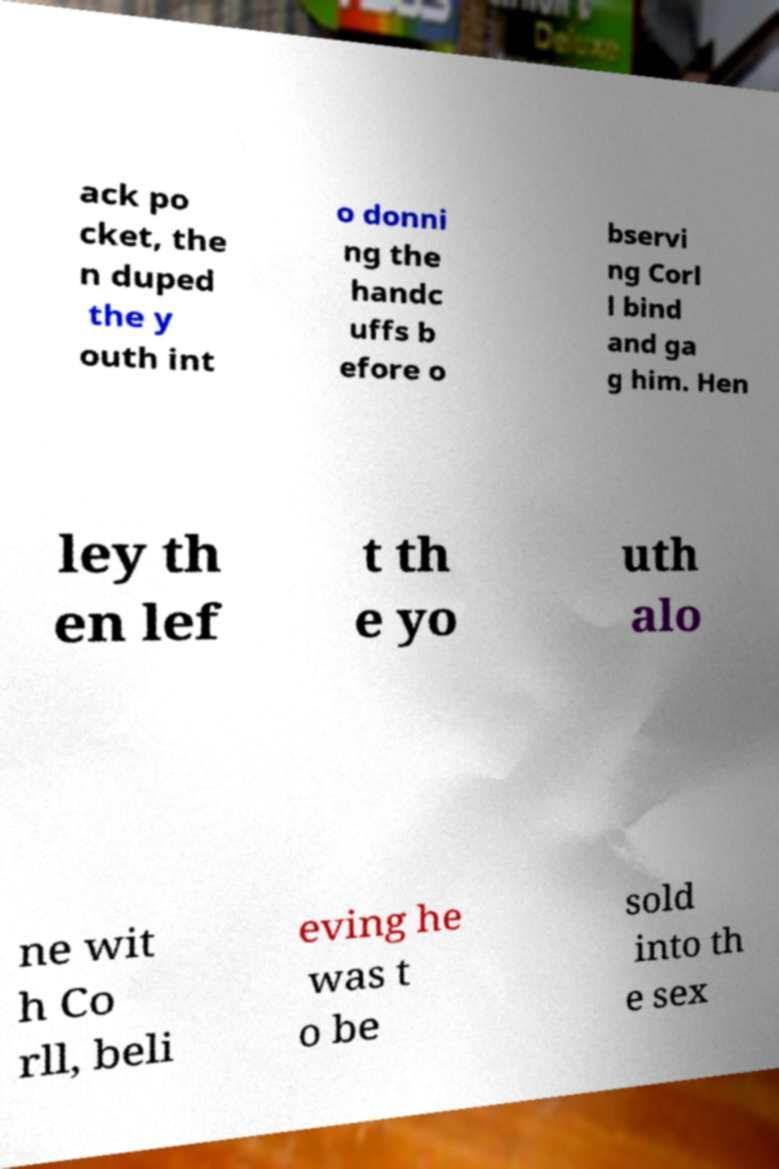Could you assist in decoding the text presented in this image and type it out clearly? ack po cket, the n duped the y outh int o donni ng the handc uffs b efore o bservi ng Corl l bind and ga g him. Hen ley th en lef t th e yo uth alo ne wit h Co rll, beli eving he was t o be sold into th e sex 